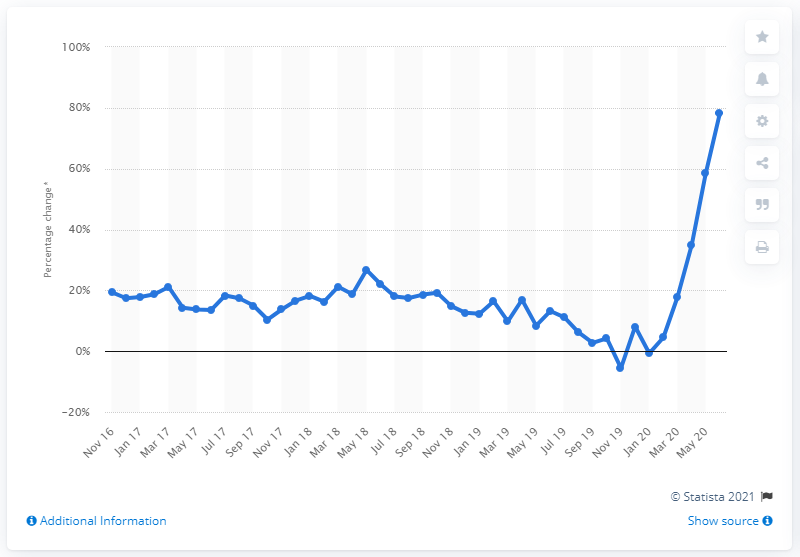Highlight a few significant elements in this photo. In June 2020, internet non-food sales showed a significant increase of 78.3% compared to January 2020. 